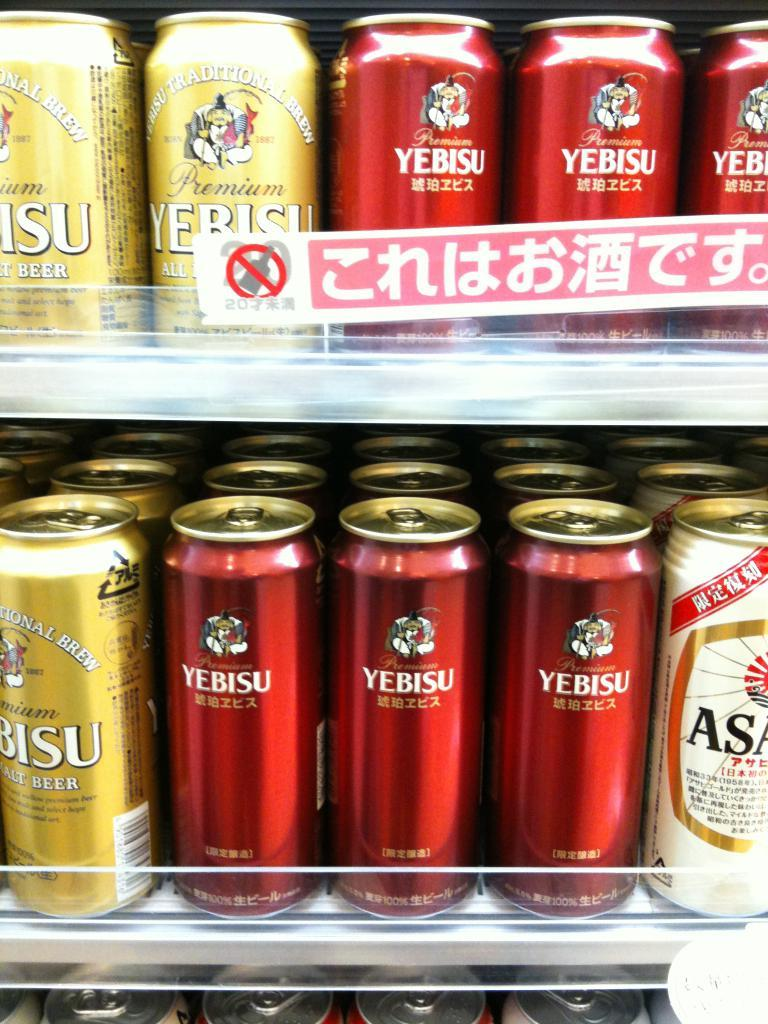Provide a one-sentence caption for the provided image. a red can that has yebisu written on it. 